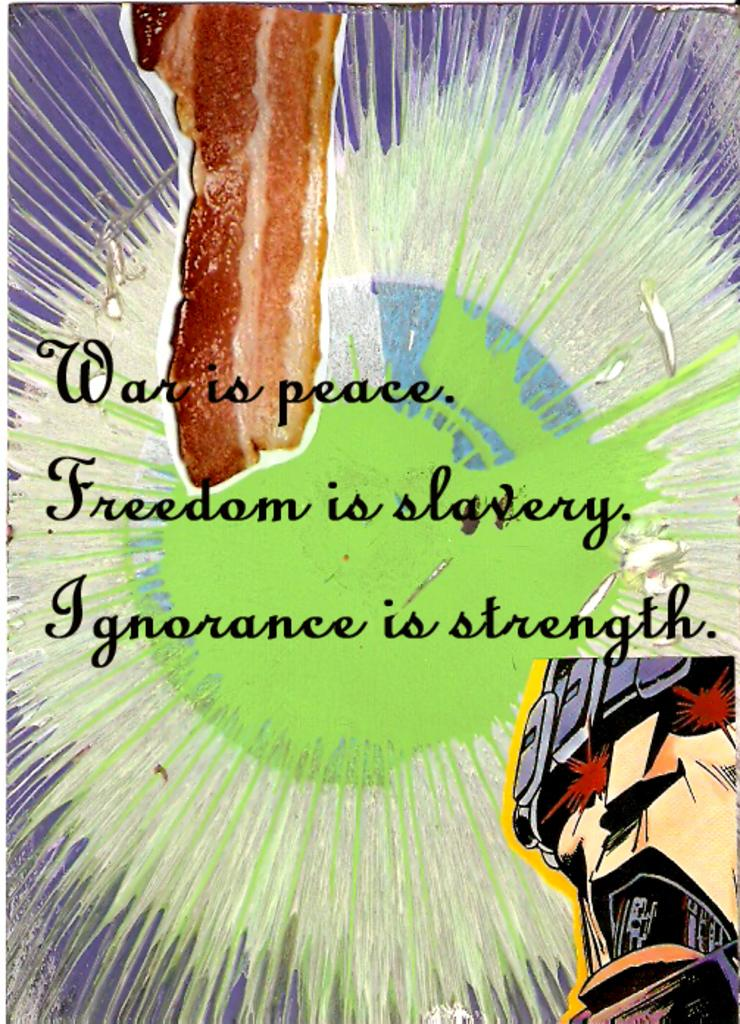<image>
Describe the image concisely. A old poster declares that people are better off living in ignorance. 